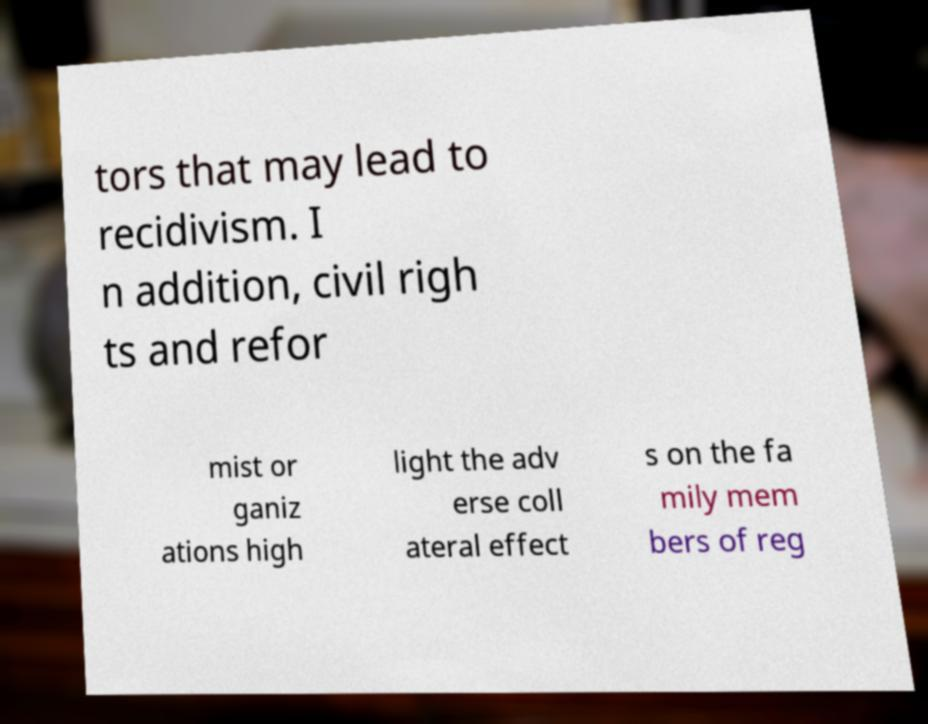Could you assist in decoding the text presented in this image and type it out clearly? tors that may lead to recidivism. I n addition, civil righ ts and refor mist or ganiz ations high light the adv erse coll ateral effect s on the fa mily mem bers of reg 